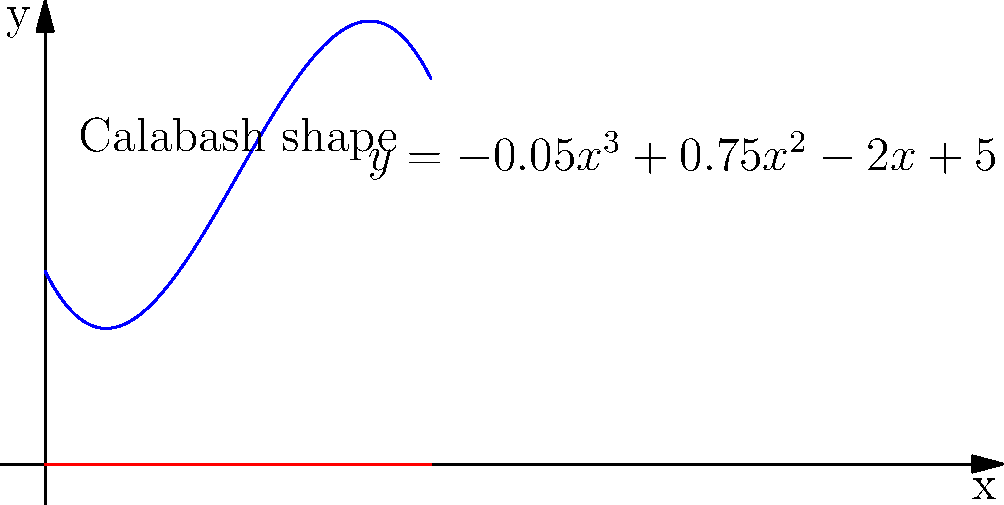A calabash gourd farmer wants to optimize the shape of their gourds using a polynomial function. The cross-section of the gourd can be modeled by the equation $y = -0.05x^3 + 0.75x^2 - 2x + 5$, where $x$ represents the horizontal distance from the stem in centimeters, and $y$ represents the radius of the gourd at that point. What is the maximum radius of the gourd, and at what distance from the stem does it occur? To find the maximum radius of the gourd and its location, we need to follow these steps:

1) The maximum point of the function occurs where its derivative equals zero. Let's find the derivative of the function:

   $f(x) = -0.05x^3 + 0.75x^2 - 2x + 5$
   $f'(x) = -0.15x^2 + 1.5x - 2$

2) Set the derivative equal to zero and solve for x:

   $-0.15x^2 + 1.5x - 2 = 0$

3) This is a quadratic equation. We can solve it using the quadratic formula:
   $x = \frac{-b \pm \sqrt{b^2 - 4ac}}{2a}$

   Where $a = -0.15$, $b = 1.5$, and $c = -2$

4) Plugging these values into the quadratic formula:

   $x = \frac{-1.5 \pm \sqrt{1.5^2 - 4(-0.15)(-2)}}{2(-0.15)}$
   $x = \frac{-1.5 \pm \sqrt{2.25 - 1.2}}{-0.3}$
   $x = \frac{-1.5 \pm \sqrt{1.05}}{-0.3}$
   $x = \frac{-1.5 \pm 1.025}{-0.3}$

5) This gives us two solutions:
   $x_1 = \frac{-1.5 + 1.025}{-0.3} \approx 1.58$
   $x_2 = \frac{-1.5 - 1.025}{-0.3} \approx 8.42$

6) The second solution (8.42) is outside our domain of interest (the gourd), so we focus on $x \approx 1.58$ cm.

7) To find the maximum radius, we plug this x-value back into our original function:

   $y = -0.05(1.58)^3 + 0.75(1.58)^2 - 2(1.58) + 5 \approx 5.35$ cm

Therefore, the maximum radius of the gourd is approximately 5.35 cm, occurring at a distance of about 1.58 cm from the stem.
Answer: Maximum radius ≈ 5.35 cm at 1.58 cm from stem 